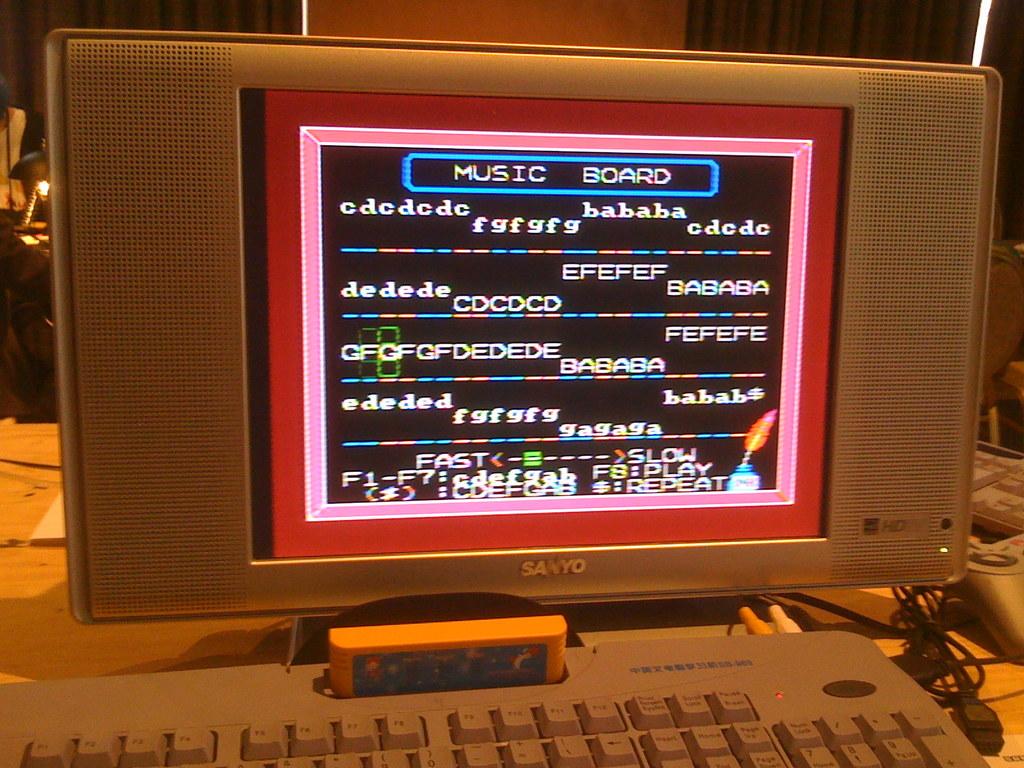What kind of board is this?
Your response must be concise. Music. What brand is the monitor?
Offer a very short reply. Sanyo. 